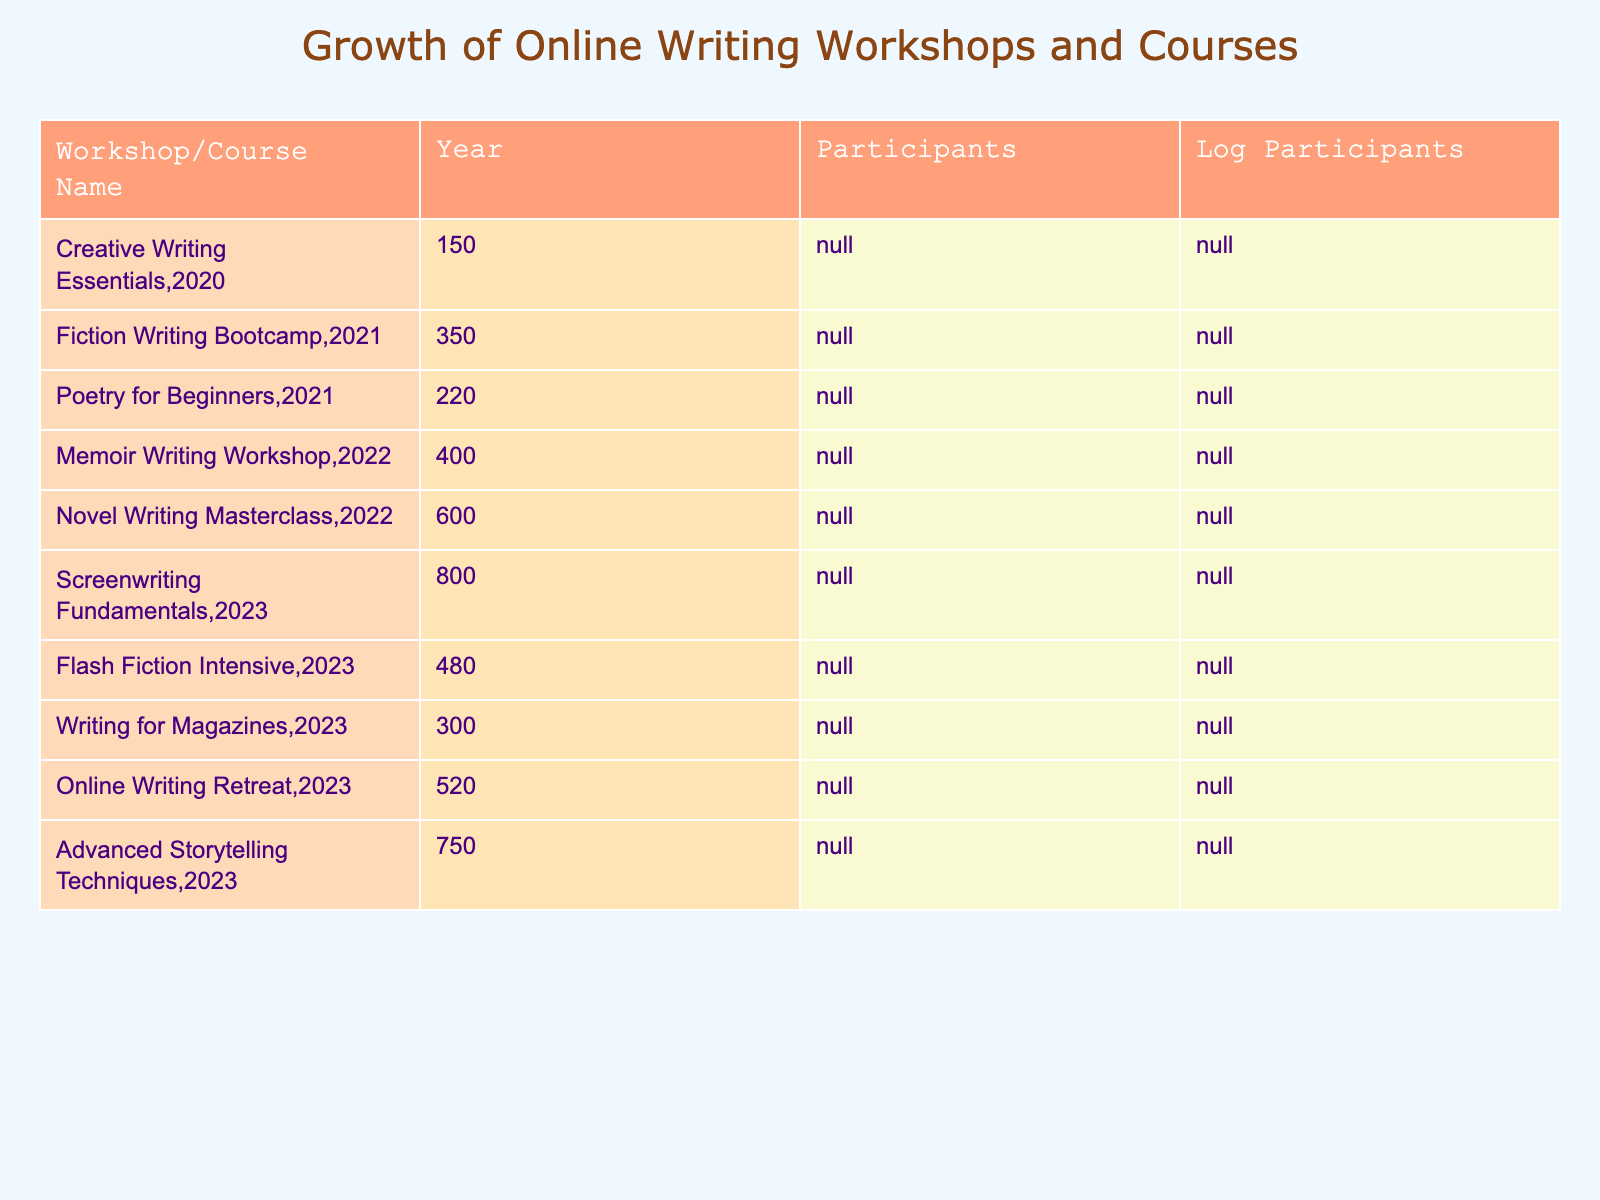What workshop had the highest number of participants in 2022? The table shows that "Novel Writing Masterclass" in 2022 had 600 participants, which is the highest number for that year.
Answer: Novel Writing Masterclass What is the total number of participants in 2023 across all listed workshops? To find the total for 2023, add the participants together: 800 + 480 + 300 + 520 + 750 = 2850.
Answer: 2850 Is the "Fiction Writing Bootcamp" workshop larger than "Poetry for Beginners"? The table indicates "Fiction Writing Bootcamp" had 350 participants while "Poetry for Beginners" had 220, so yes, it is larger.
Answer: Yes What is the average number of participants for the workshops in 2021? For 2021, there are two workshops: "Fiction Writing Bootcamp" with 350 and "Poetry for Beginners" with 220. Adding these gives 350 + 220 = 570 participants. To find the average, divide 570 by 2, yielding 285.
Answer: 285 Which year had the overall lowest participation? Looking through the years, 2020 had only 150 participants, which is lower than any year listed in the table.
Answer: 2020 Is there any workshop in 2023 that has fewer than 500 participants? Reviewing the 2023 data reveals "Writing for Magazines" with 300 participants, which is fewer than 500, confirming the presence of such a workshop.
Answer: Yes How many more participants did "Screenwriting Fundamentals" have than the "Online Writing Retreat" in 2023? "Screenwriting Fundamentals" had 800 participants, and "Online Writing Retreat" had 520, so calculating the difference gives us 800 - 520 = 280 more participants.
Answer: 280 Which workshop showed the most significant increase in participants from 2021 to 2022? Comparing workshops from 2021 to 2022, the "Memoir Writing Workshop" increased from no previous year listed but in 2022 had 400 participants, and "Fiction Writing Bootcamp" increased from 350 in 2021 to 0 in prior years, so the increase of 0 to 400 is the greatest.
Answer: Memoir Writing Workshop What is the logarithmic value of participants for the "Advanced Storytelling Techniques" workshop? According to the table, "Advanced Storytelling Techniques" had 750 participants. The logarithmic value is calculated as log10(750), which is approximately 2.875.
Answer: 2.875 